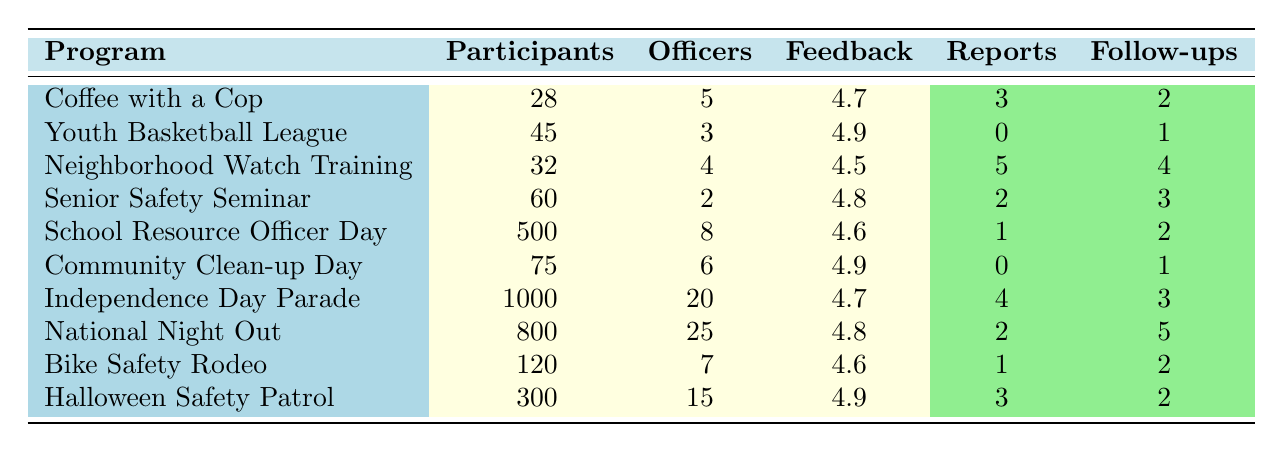What program had the highest number of participants? The "Independence Day Parade" had the highest number of participants listed in the table with 1000 participants.
Answer: Independence Day Parade How many crime reports were received during the "Neighborhood Watch Training"? The table specifies that during the "Neighborhood Watch Training," 5 crime reports were received.
Answer: 5 What is the average community feedback score for the programs listed? To calculate the average feedback score, we sum the scores: (4.7 + 4.9 + 4.5 + 4.8 + 4.6 + 4.9 + 4.7 + 4.8 + 4.6 + 4.9) = 46.4. There are 10 programs, hence the average is 46.4 / 10 = 4.64.
Answer: 4.64 Did the "Community Clean-up Day" generate any crime reports? According to the table, the "Community Clean-up Day" had 0 crime reports received.
Answer: Yes Which program had the lowest number of follow-up actions? The "Youth Basketball League" had the lowest number of follow-up actions with just 1 recorded action.
Answer: Youth Basketball League What was the total number of participants across all events? To find the total, we add the participants from each program: 28 + 45 + 32 + 60 + 500 + 75 + 1000 + 800 + 120 + 300 = 1960.
Answer: 1960 Was community feedback for the "Coffee with a Cop" program higher than that for the "School Resource Officer Day"? The feedback for "Coffee with a Cop" is 4.7, while for "School Resource Officer Day," it is 4.6, thus confirming that the feedback for "Coffee with a Cop" is indeed higher.
Answer: Yes What is the difference in the number of officers involved between the "Independence Day Parade" and the "Senior Safety Seminar"? The "Independence Day Parade" involved 20 officers, whereas the "Senior Safety Seminar" involved 2 officers. The difference is 20 - 2 = 18 officers.
Answer: 18 Which program received the highest community feedback score? The "Youth Basketball League" received the highest community feedback score of 4.9 according to the table.
Answer: Youth Basketball League 